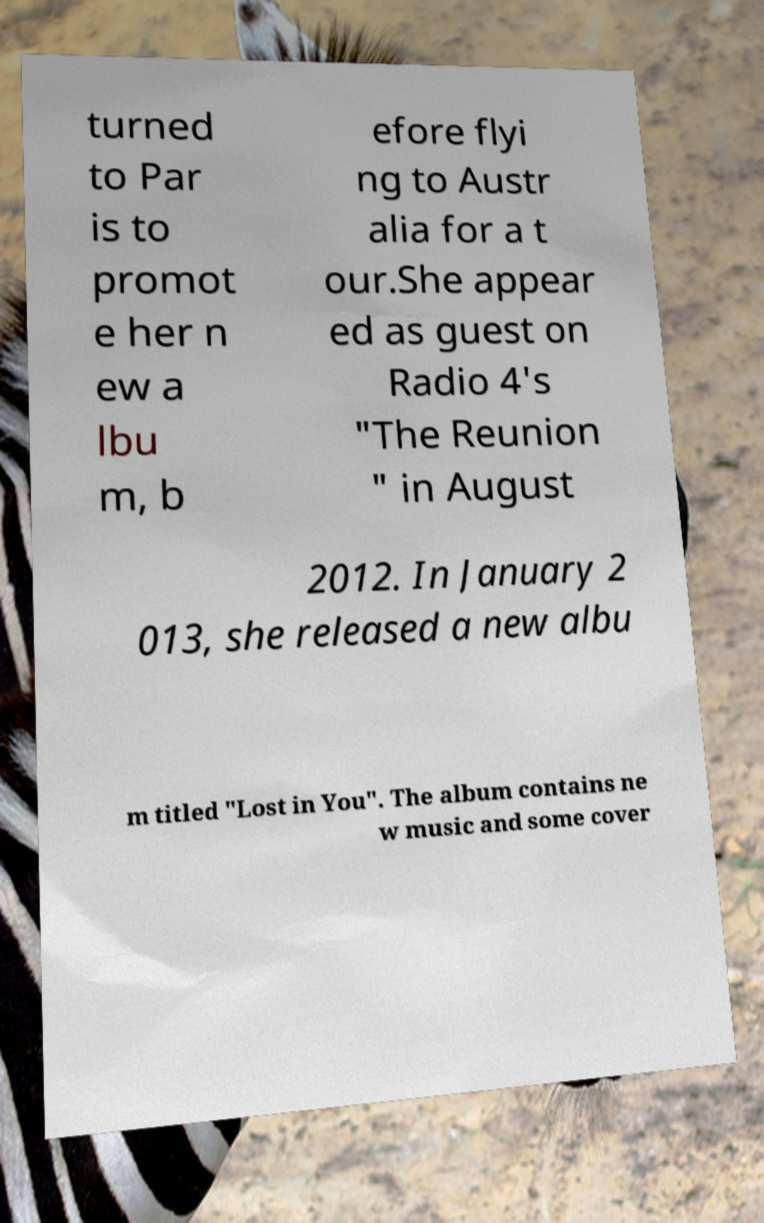For documentation purposes, I need the text within this image transcribed. Could you provide that? turned to Par is to promot e her n ew a lbu m, b efore flyi ng to Austr alia for a t our.She appear ed as guest on Radio 4's "The Reunion " in August 2012. In January 2 013, she released a new albu m titled "Lost in You". The album contains ne w music and some cover 